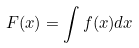<formula> <loc_0><loc_0><loc_500><loc_500>F ( x ) = \int f ( x ) d x</formula> 